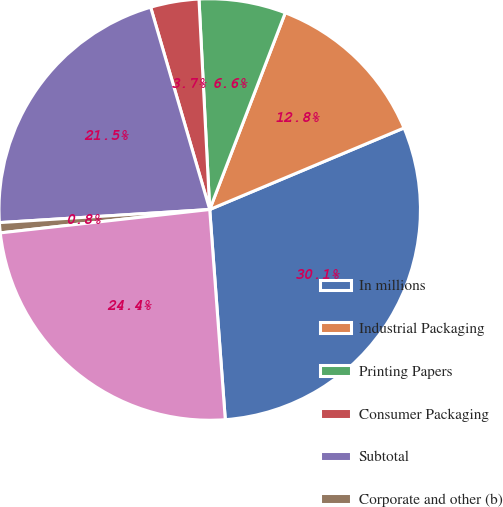<chart> <loc_0><loc_0><loc_500><loc_500><pie_chart><fcel>In millions<fcel>Industrial Packaging<fcel>Printing Papers<fcel>Consumer Packaging<fcel>Subtotal<fcel>Corporate and other (b)<fcel>Total<nl><fcel>30.15%<fcel>12.84%<fcel>6.65%<fcel>3.71%<fcel>21.47%<fcel>0.78%<fcel>24.41%<nl></chart> 